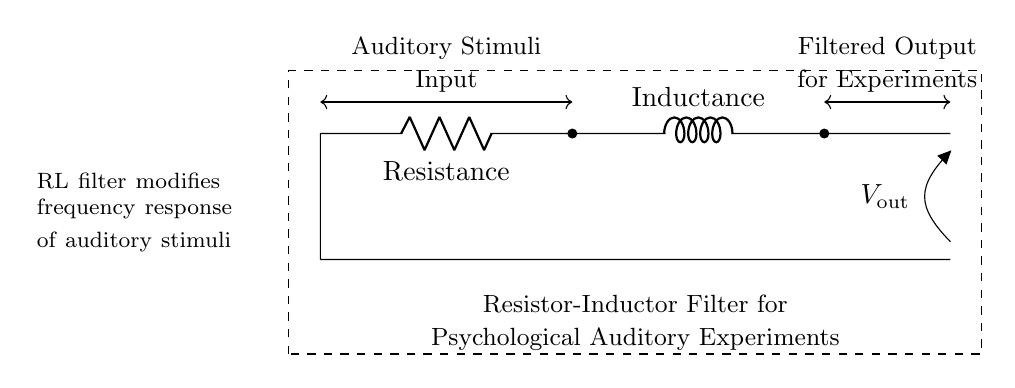What are the main components shown in the circuit? The main components are a resistor and an inductor, which can be identified by their respective labels and symbols in the circuit diagram.
Answer: Resistor and Inductor What is the purpose of this Resistor-Inductor filter? This filter is designed to modify the frequency response of auditory stimuli, as indicated in the accompanying text within the circuit diagram.
Answer: Modify frequency response What type of signals does the input represent? The input signals represent auditory stimuli that are intended for psychological experiments, as labeled in the diagram.
Answer: Auditory stimuli How does the voltage change across the filter? The voltage output is taken after the inductor, implying it reflects the filtered signal, which is modified based on the circuit's characteristics and the input.
Answer: Filtered output What happens to frequencies higher than a certain threshold in this filter? The filter typically attenuates higher frequencies due to the properties of the resistor and inductor combination, causing a low-pass filter effect.
Answer: Attenuated Why might a researcher choose to use this type of filter in their study? Researchers may use this filter to isolate specific frequency ranges of auditory stimuli relevant to their study on moral decision-making, limiting unwanted noise or frequencies.
Answer: Isolate specific frequencies 